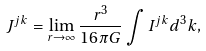<formula> <loc_0><loc_0><loc_500><loc_500>J ^ { j k } = \lim _ { r \to \infty } \frac { r ^ { 3 } } { 1 6 \pi G } \int I ^ { j k } d ^ { 3 } k ,</formula> 